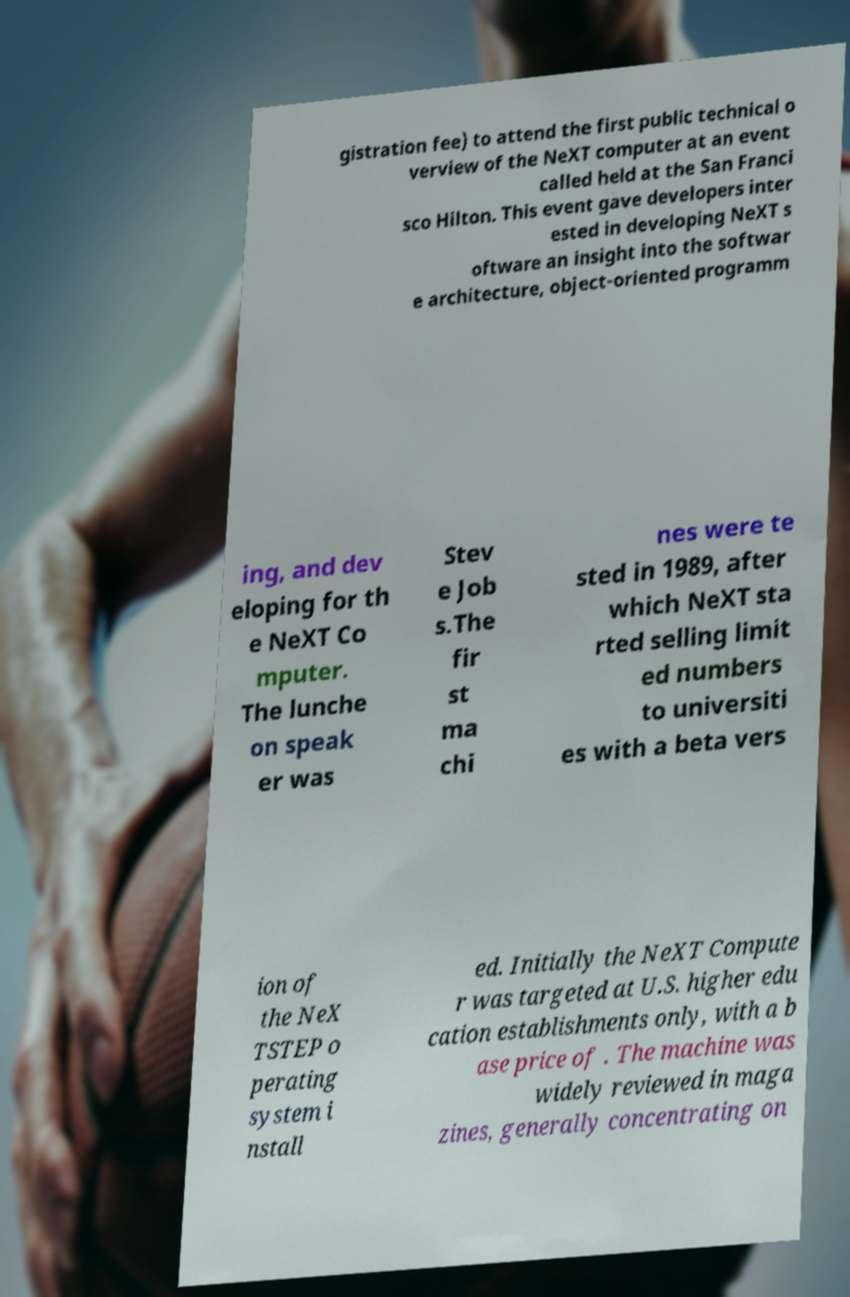For documentation purposes, I need the text within this image transcribed. Could you provide that? gistration fee) to attend the first public technical o verview of the NeXT computer at an event called held at the San Franci sco Hilton. This event gave developers inter ested in developing NeXT s oftware an insight into the softwar e architecture, object-oriented programm ing, and dev eloping for th e NeXT Co mputer. The lunche on speak er was Stev e Job s.The fir st ma chi nes were te sted in 1989, after which NeXT sta rted selling limit ed numbers to universiti es with a beta vers ion of the NeX TSTEP o perating system i nstall ed. Initially the NeXT Compute r was targeted at U.S. higher edu cation establishments only, with a b ase price of . The machine was widely reviewed in maga zines, generally concentrating on 